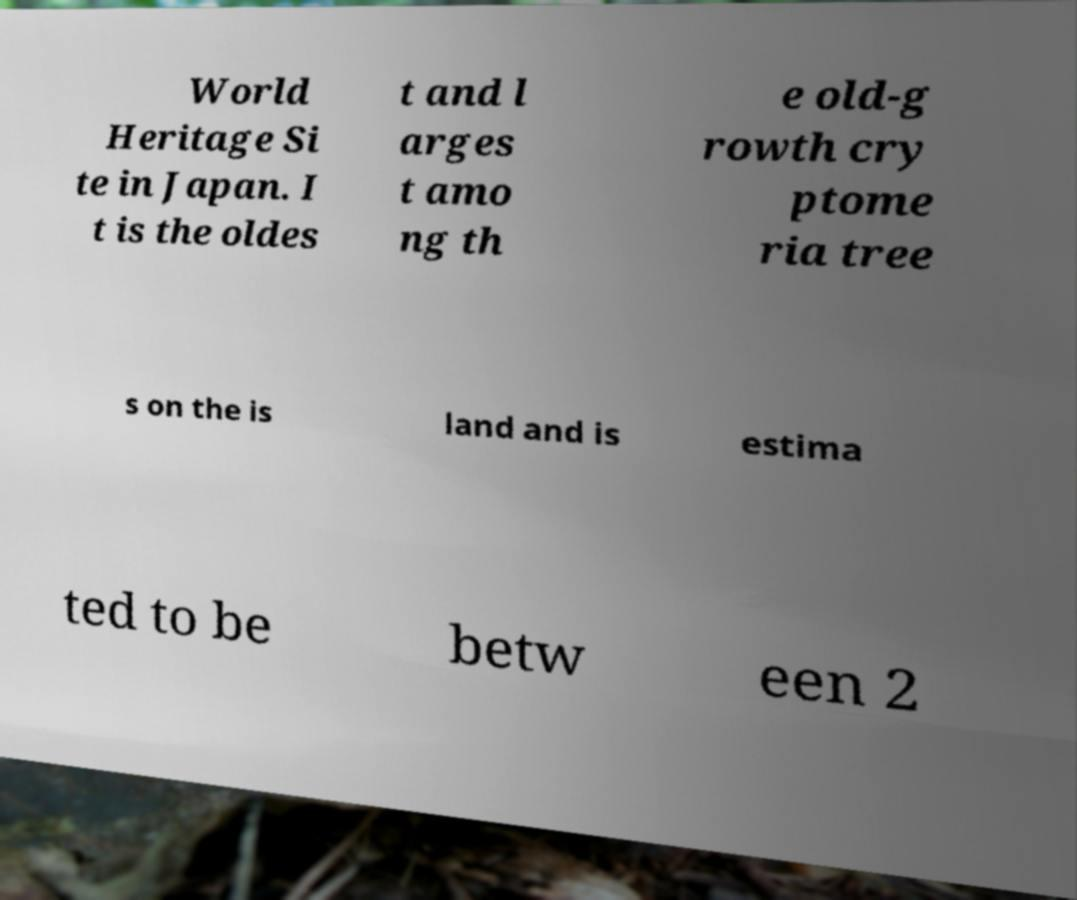What messages or text are displayed in this image? I need them in a readable, typed format. World Heritage Si te in Japan. I t is the oldes t and l arges t amo ng th e old-g rowth cry ptome ria tree s on the is land and is estima ted to be betw een 2 